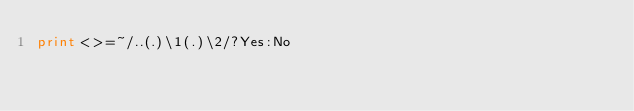Convert code to text. <code><loc_0><loc_0><loc_500><loc_500><_Perl_>print<>=~/..(.)\1(.)\2/?Yes:No</code> 